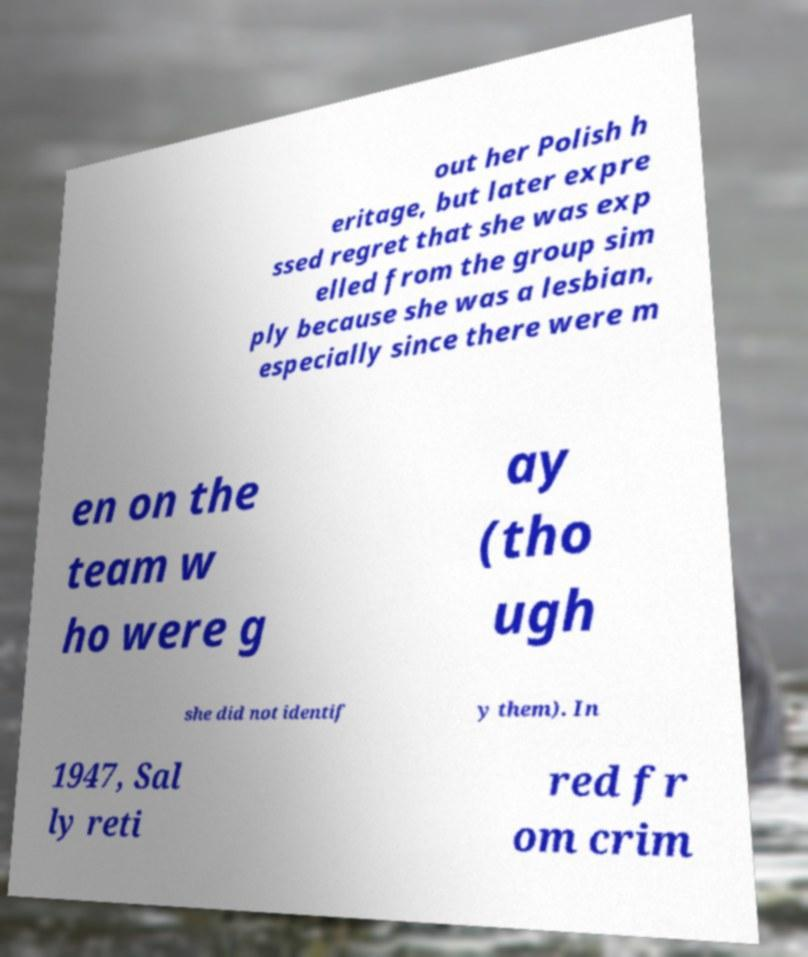For documentation purposes, I need the text within this image transcribed. Could you provide that? out her Polish h eritage, but later expre ssed regret that she was exp elled from the group sim ply because she was a lesbian, especially since there were m en on the team w ho were g ay (tho ugh she did not identif y them). In 1947, Sal ly reti red fr om crim 